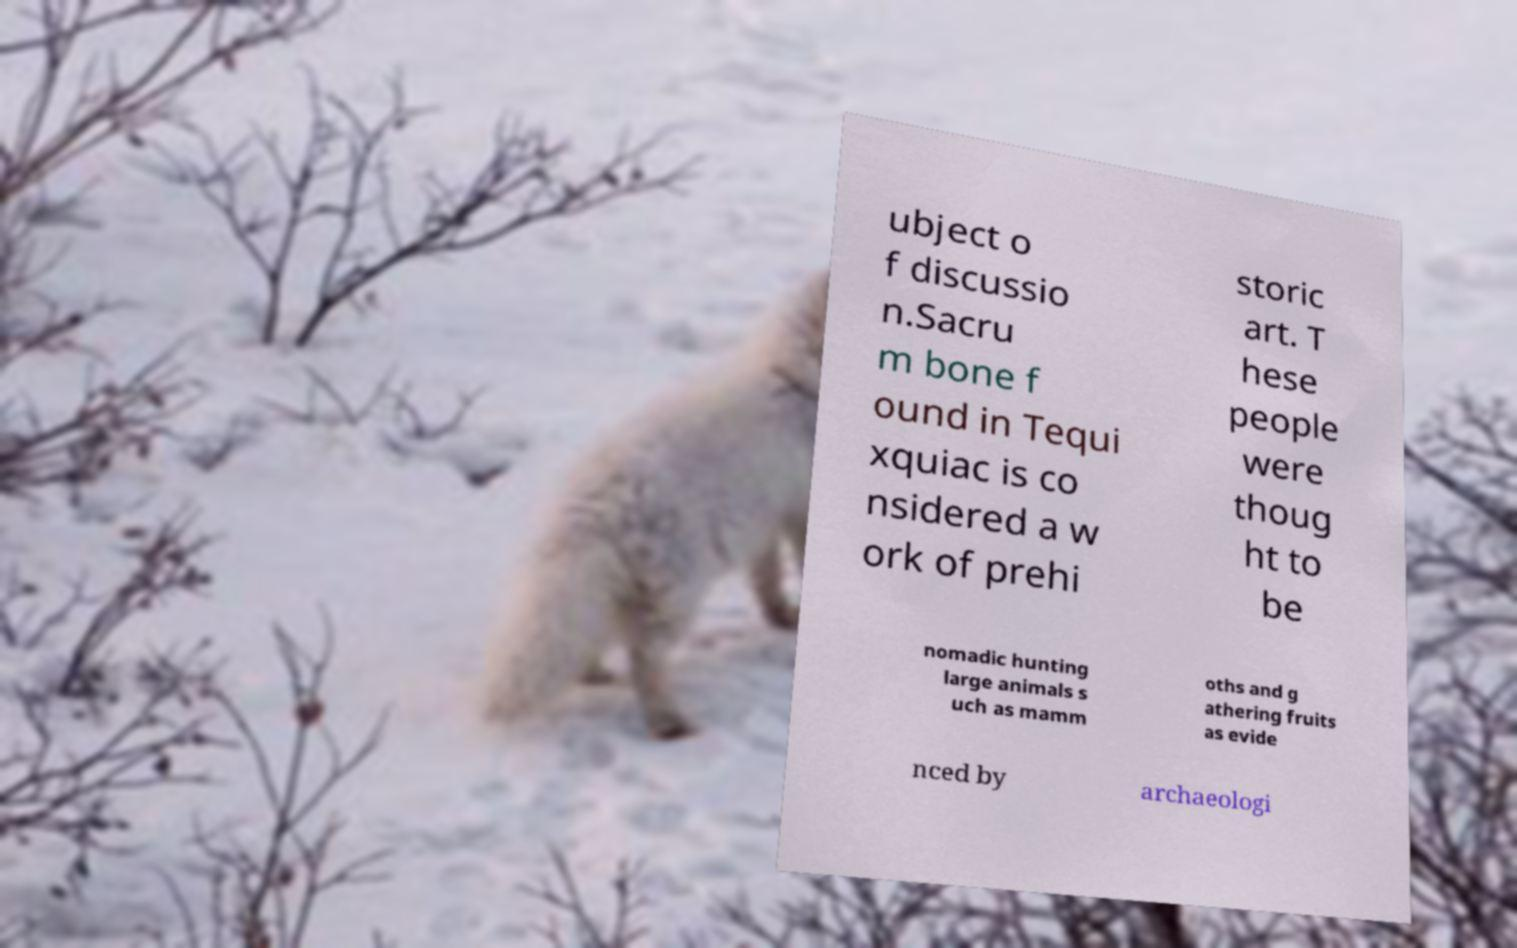Can you accurately transcribe the text from the provided image for me? ubject o f discussio n.Sacru m bone f ound in Tequi xquiac is co nsidered a w ork of prehi storic art. T hese people were thoug ht to be nomadic hunting large animals s uch as mamm oths and g athering fruits as evide nced by archaeologi 